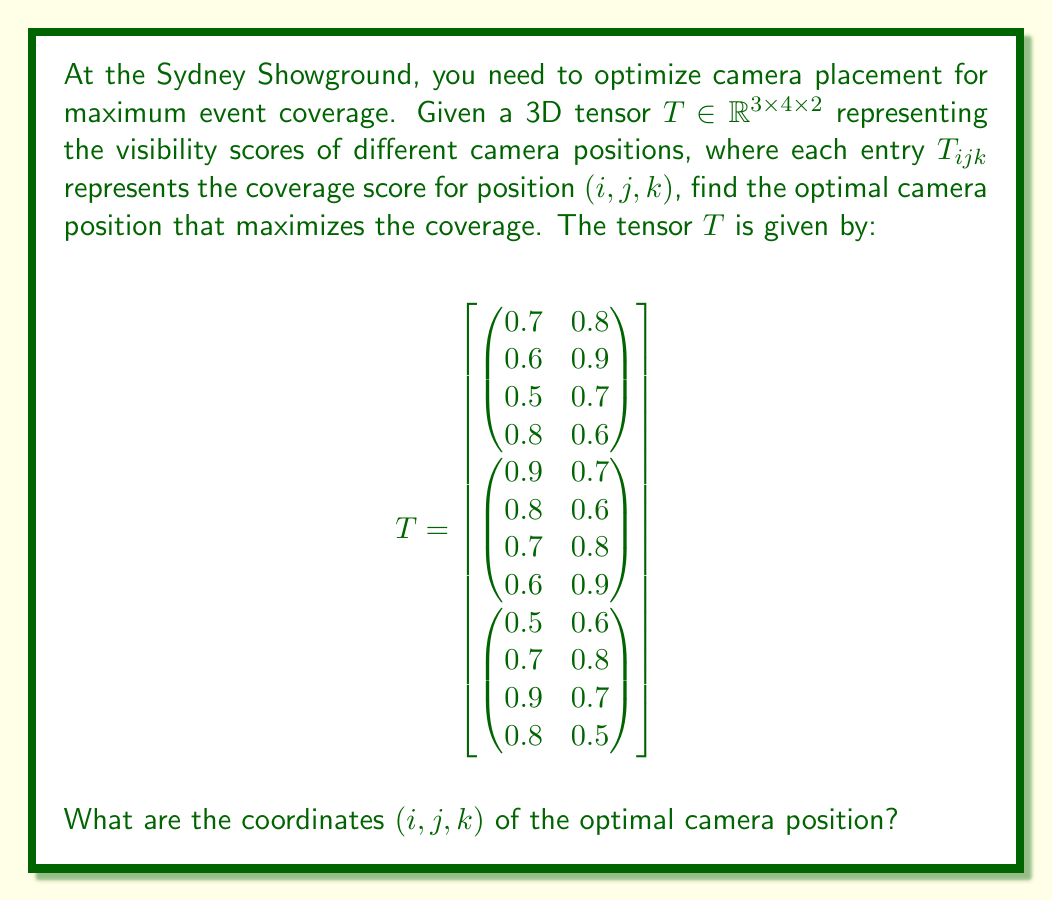Teach me how to tackle this problem. To find the optimal camera position, we need to locate the maximum value in the given tensor $T$. Let's approach this step-by-step:

1) First, let's understand the structure of the tensor:
   - It has 3 "layers" (i = 1, 2, 3)
   - Each layer has 4 rows (j = 1, 2, 3, 4)
   - Each row has 2 columns (k = 1, 2)

2) Now, we'll iterate through each element of the tensor to find the maximum value:

   Layer 1 (i = 1):
   - Max value: 0.9 at position (1,2,2)

   Layer 2 (i = 2):
   - Max value: 0.9 at position (2,1,1)

   Layer 3 (i = 3):
   - Max value: 0.9 at position (3,3,1)

3) We have three positions with the same maximum value of 0.9:
   (1,2,2), (2,1,1), and (3,3,1)

4) In case of a tie, we can choose any of these positions. Let's select the first one we encountered: (2,1,1).

Therefore, the optimal camera position is at coordinates (2,1,1), which corresponds to the second layer, first row, and first column of the tensor.
Answer: (2,1,1) 